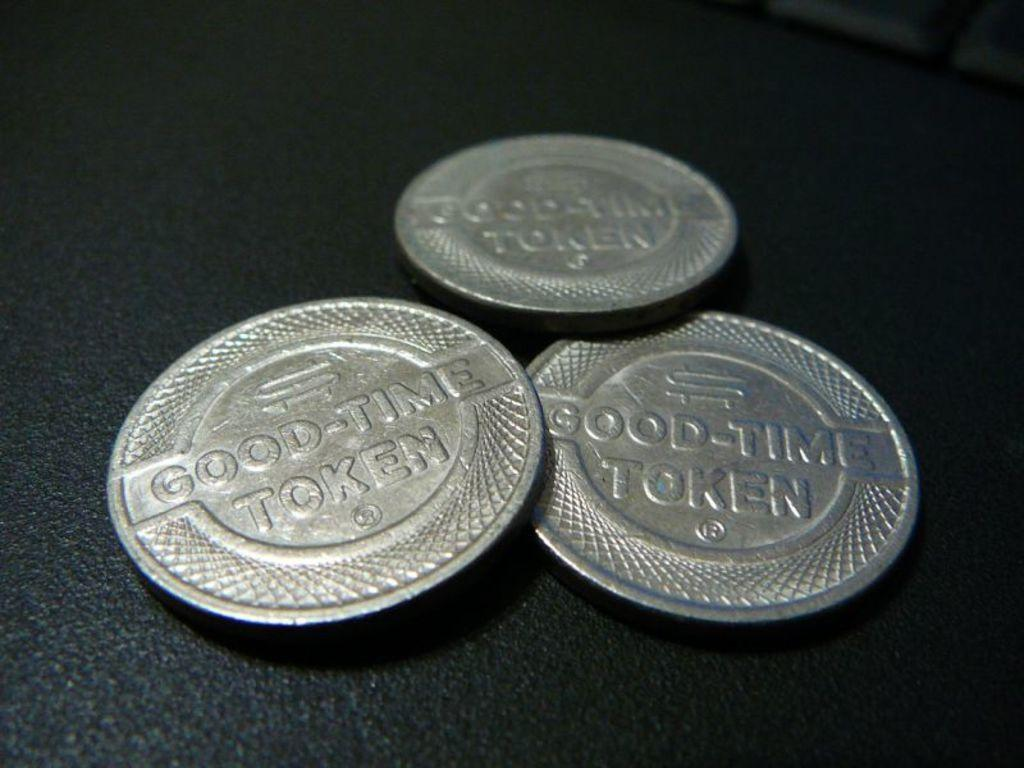<image>
Relay a brief, clear account of the picture shown. Three silver Good-Time tokens are sitting on a table. 